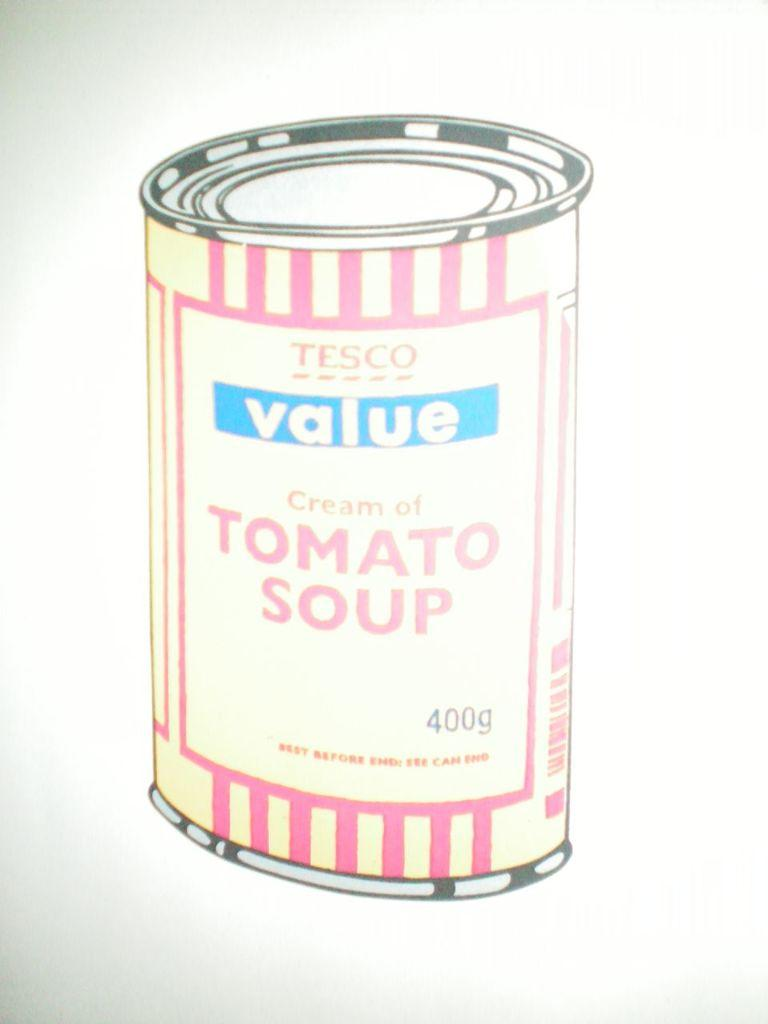Provide a one-sentence caption for the provided image. A Tesco value brand can of Tomato Soup. 